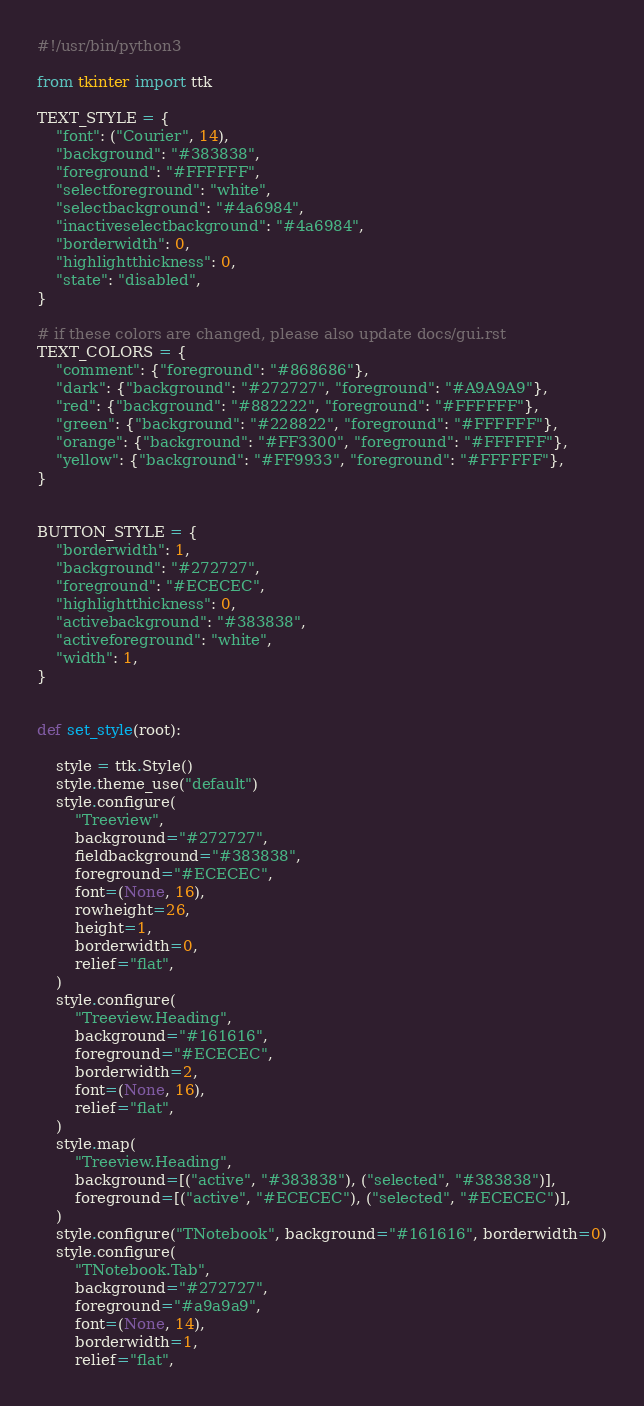<code> <loc_0><loc_0><loc_500><loc_500><_Python_>#!/usr/bin/python3

from tkinter import ttk

TEXT_STYLE = {
    "font": ("Courier", 14),
    "background": "#383838",
    "foreground": "#FFFFFF",
    "selectforeground": "white",
    "selectbackground": "#4a6984",
    "inactiveselectbackground": "#4a6984",
    "borderwidth": 0,
    "highlightthickness": 0,
    "state": "disabled",
}

# if these colors are changed, please also update docs/gui.rst
TEXT_COLORS = {
    "comment": {"foreground": "#868686"},
    "dark": {"background": "#272727", "foreground": "#A9A9A9"},
    "red": {"background": "#882222", "foreground": "#FFFFFF"},
    "green": {"background": "#228822", "foreground": "#FFFFFF"},
    "orange": {"background": "#FF3300", "foreground": "#FFFFFF"},
    "yellow": {"background": "#FF9933", "foreground": "#FFFFFF"},
}


BUTTON_STYLE = {
    "borderwidth": 1,
    "background": "#272727",
    "foreground": "#ECECEC",
    "highlightthickness": 0,
    "activebackground": "#383838",
    "activeforeground": "white",
    "width": 1,
}


def set_style(root):

    style = ttk.Style()
    style.theme_use("default")
    style.configure(
        "Treeview",
        background="#272727",
        fieldbackground="#383838",
        foreground="#ECECEC",
        font=(None, 16),
        rowheight=26,
        height=1,
        borderwidth=0,
        relief="flat",
    )
    style.configure(
        "Treeview.Heading",
        background="#161616",
        foreground="#ECECEC",
        borderwidth=2,
        font=(None, 16),
        relief="flat",
    )
    style.map(
        "Treeview.Heading",
        background=[("active", "#383838"), ("selected", "#383838")],
        foreground=[("active", "#ECECEC"), ("selected", "#ECECEC")],
    )
    style.configure("TNotebook", background="#161616", borderwidth=0)
    style.configure(
        "TNotebook.Tab",
        background="#272727",
        foreground="#a9a9a9",
        font=(None, 14),
        borderwidth=1,
        relief="flat",</code> 